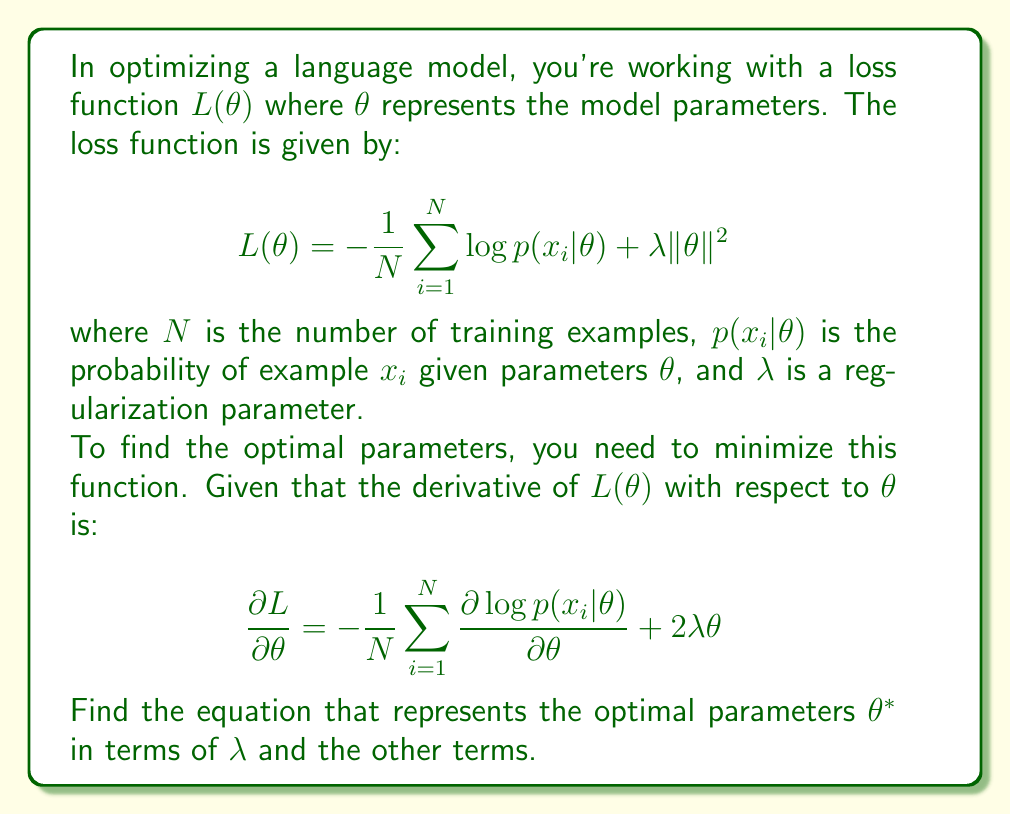Provide a solution to this math problem. Let's approach this step-by-step:

1) To find the optimal parameters $\theta^*$, we need to set the derivative of the loss function to zero:

   $$\frac{\partial L}{\partial \theta} = 0$$

2) Substituting the given derivative:

   $$-\frac{1}{N}\sum_{i=1}^N \frac{\partial \log p(x_i|\theta)}{\partial \theta} + 2\lambda\theta = 0$$

3) Let's simplify by denoting $\frac{1}{N}\sum_{i=1}^N \frac{\partial \log p(x_i|\theta)}{\partial \theta}$ as $g(\theta)$. This term represents the average gradient of the log-likelihood across all training examples.

4) Our equation becomes:

   $$-g(\theta) + 2\lambda\theta = 0$$

5) Adding $g(\theta)$ to both sides:

   $$2\lambda\theta = g(\theta)$$

6) Dividing both sides by $2\lambda$:

   $$\theta = \frac{g(\theta)}{2\lambda}$$

7) This equation represents the optimal parameters $\theta^*$. It shows that the optimal parameters are proportional to the average gradient of the log-likelihood, with the regularization parameter $\lambda$ controlling the magnitude.
Answer: $$\theta^* = \frac{g(\theta)}{2\lambda}$$
where $g(\theta) = \frac{1}{N}\sum_{i=1}^N \frac{\partial \log p(x_i|\theta)}{\partial \theta}$ 